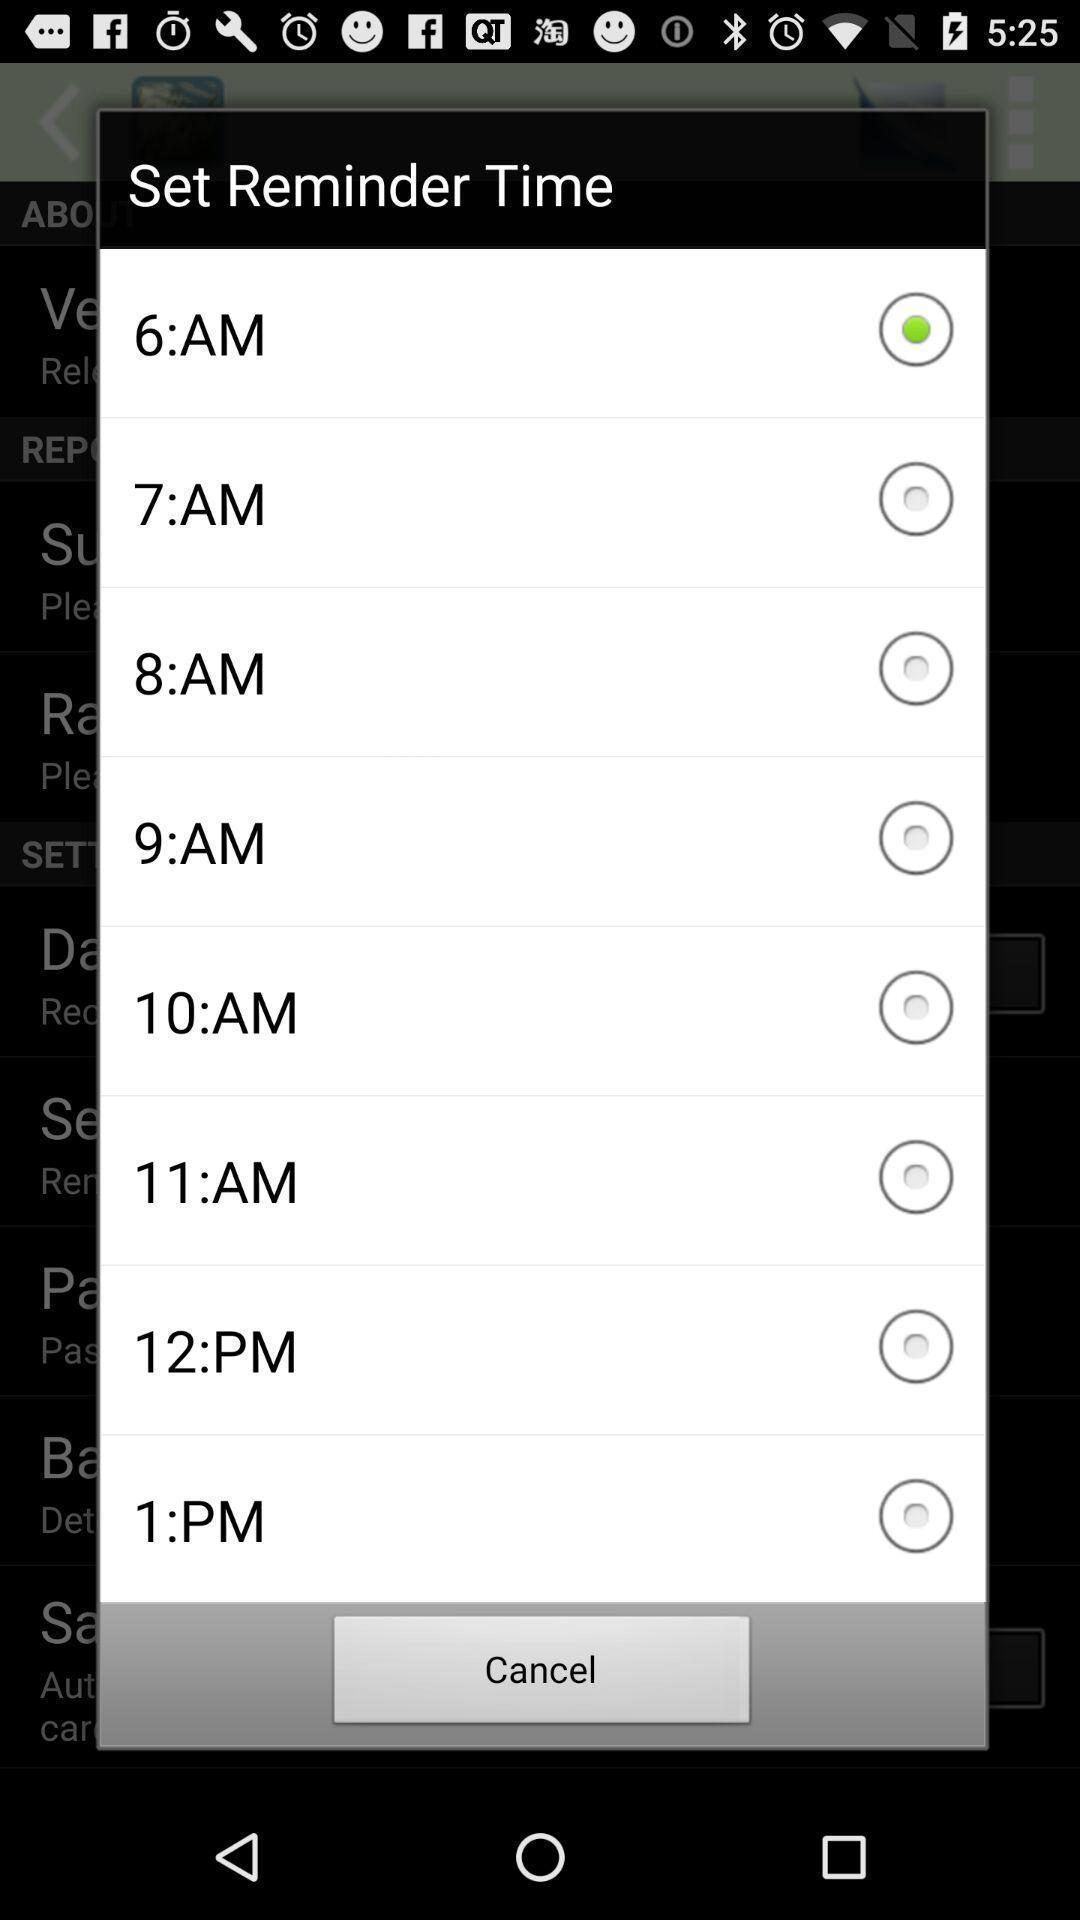Provide a detailed account of this screenshot. Popup for time reminder in the application. 